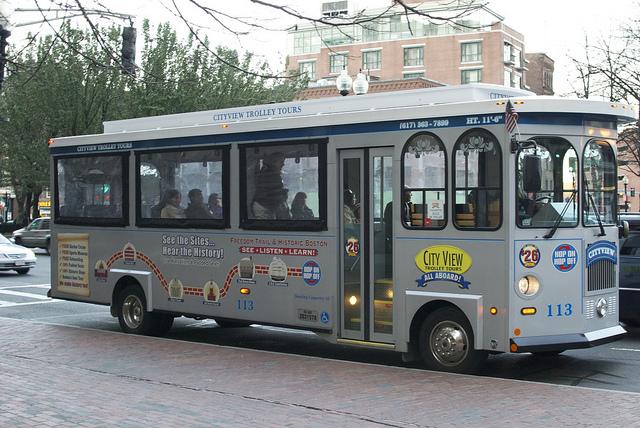What number is on the side of the bus?
Be succinct. 113. What color is this bus?
Keep it brief. Gray. What color is the bus?
Answer briefly. Gray. What is the name of the company?
Write a very short answer. City view. What country is this trolley driving in?
Write a very short answer. Usa. Is this a double decker bus?
Keep it brief. No. Does this trolley look empty of passengers?
Keep it brief. No. Is this in the United States?
Give a very brief answer. Yes. 